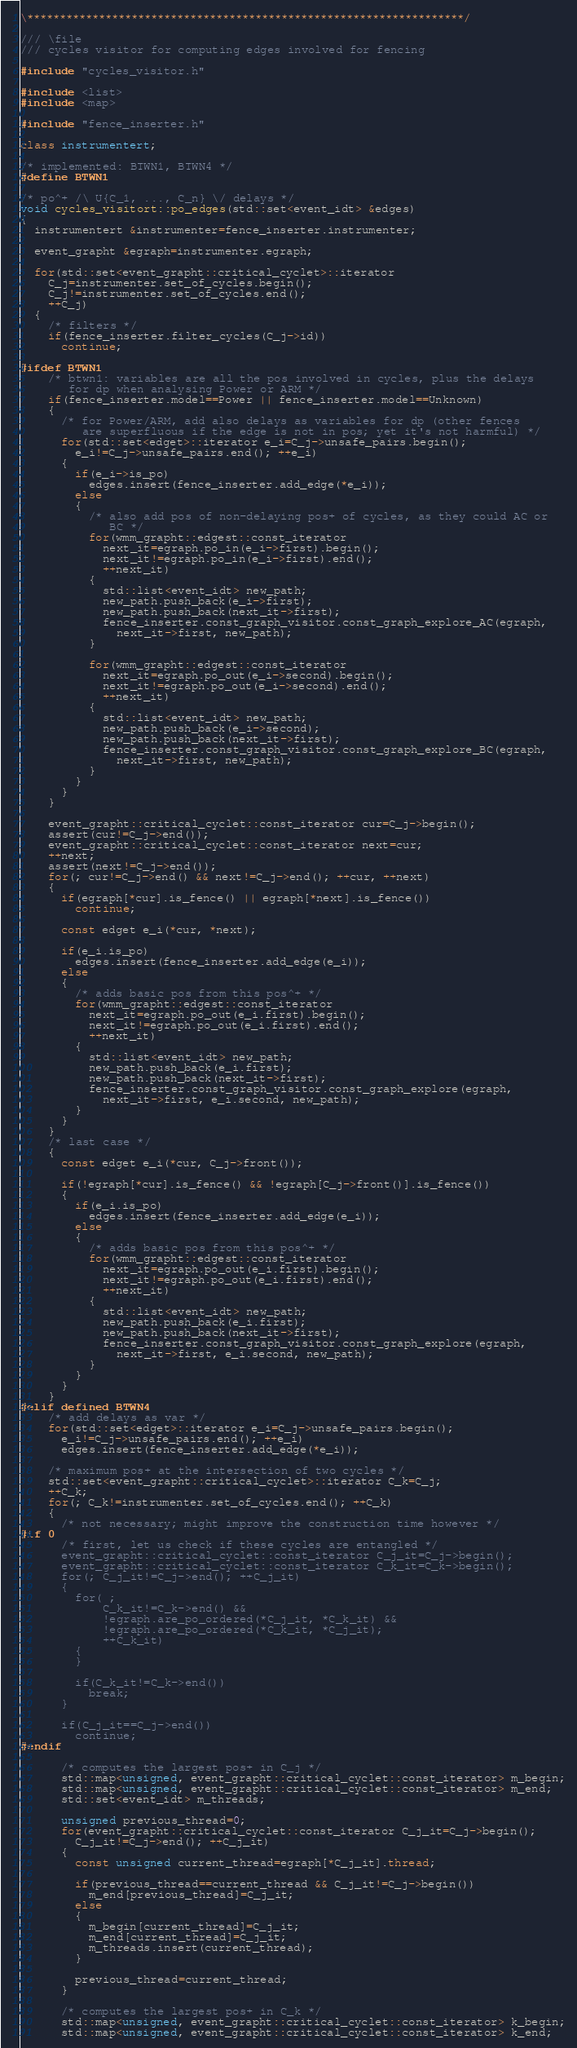<code> <loc_0><loc_0><loc_500><loc_500><_C++_>\*******************************************************************/

/// \file
/// cycles visitor for computing edges involved for fencing

#include "cycles_visitor.h"

#include <list>
#include <map>

#include "fence_inserter.h"

class instrumentert;

/* implemented: BTWN1, BTWN4 */
#define BTWN1

/* po^+ /\ U{C_1, ..., C_n} \/ delays */
void cycles_visitort::po_edges(std::set<event_idt> &edges)
{
  instrumentert &instrumenter=fence_inserter.instrumenter;

  event_grapht &egraph=instrumenter.egraph;

  for(std::set<event_grapht::critical_cyclet>::iterator
    C_j=instrumenter.set_of_cycles.begin();
    C_j!=instrumenter.set_of_cycles.end();
    ++C_j)
  {
    /* filters */
    if(fence_inserter.filter_cycles(C_j->id))
      continue;

#ifdef BTWN1
    /* btwn1: variables are all the pos involved in cycles, plus the delays
       for dp when analysing Power or ARM */
    if(fence_inserter.model==Power || fence_inserter.model==Unknown)
    {
      /* for Power/ARM, add also delays as variables for dp (other fences
         are superfluous if the edge is not in pos; yet it's not harmful) */
      for(std::set<edget>::iterator e_i=C_j->unsafe_pairs.begin();
        e_i!=C_j->unsafe_pairs.end(); ++e_i)
      {
        if(e_i->is_po)
          edges.insert(fence_inserter.add_edge(*e_i));
        else
        {
          /* also add pos of non-delaying pos+ of cycles, as they could AC or
             BC */
          for(wmm_grapht::edgest::const_iterator
            next_it=egraph.po_in(e_i->first).begin();
            next_it!=egraph.po_in(e_i->first).end();
            ++next_it)
          {
            std::list<event_idt> new_path;
            new_path.push_back(e_i->first);
            new_path.push_back(next_it->first);
            fence_inserter.const_graph_visitor.const_graph_explore_AC(egraph,
              next_it->first, new_path);
          }

          for(wmm_grapht::edgest::const_iterator
            next_it=egraph.po_out(e_i->second).begin();
            next_it!=egraph.po_out(e_i->second).end();
            ++next_it)
          {
            std::list<event_idt> new_path;
            new_path.push_back(e_i->second);
            new_path.push_back(next_it->first);
            fence_inserter.const_graph_visitor.const_graph_explore_BC(egraph,
              next_it->first, new_path);
          }
        }
      }
    }

    event_grapht::critical_cyclet::const_iterator cur=C_j->begin();
    assert(cur!=C_j->end());
    event_grapht::critical_cyclet::const_iterator next=cur;
    ++next;
    assert(next!=C_j->end());
    for(; cur!=C_j->end() && next!=C_j->end(); ++cur, ++next)
    {
      if(egraph[*cur].is_fence() || egraph[*next].is_fence())
        continue;

      const edget e_i(*cur, *next);

      if(e_i.is_po)
        edges.insert(fence_inserter.add_edge(e_i));
      else
      {
        /* adds basic pos from this pos^+ */
        for(wmm_grapht::edgest::const_iterator
          next_it=egraph.po_out(e_i.first).begin();
          next_it!=egraph.po_out(e_i.first).end();
          ++next_it)
        {
          std::list<event_idt> new_path;
          new_path.push_back(e_i.first);
          new_path.push_back(next_it->first);
          fence_inserter.const_graph_visitor.const_graph_explore(egraph,
            next_it->first, e_i.second, new_path);
        }
      }
    }
    /* last case */
    {
      const edget e_i(*cur, C_j->front());

      if(!egraph[*cur].is_fence() && !egraph[C_j->front()].is_fence())
      {
        if(e_i.is_po)
          edges.insert(fence_inserter.add_edge(e_i));
        else
        {
          /* adds basic pos from this pos^+ */
          for(wmm_grapht::edgest::const_iterator
            next_it=egraph.po_out(e_i.first).begin();
            next_it!=egraph.po_out(e_i.first).end();
            ++next_it)
          {
            std::list<event_idt> new_path;
            new_path.push_back(e_i.first);
            new_path.push_back(next_it->first);
            fence_inserter.const_graph_visitor.const_graph_explore(egraph,
              next_it->first, e_i.second, new_path);
          }
        }
      }
    }
#elif defined BTWN4
    /* add delays as var */
    for(std::set<edget>::iterator e_i=C_j->unsafe_pairs.begin();
      e_i!=C_j->unsafe_pairs.end(); ++e_i)
      edges.insert(fence_inserter.add_edge(*e_i));

    /* maximum pos+ at the intersection of two cycles */
    std::set<event_grapht::critical_cyclet>::iterator C_k=C_j;
    ++C_k;
    for(; C_k!=instrumenter.set_of_cycles.end(); ++C_k)
    {
      /* not necessary; might improve the construction time however */
#if 0
      /* first, let us check if these cycles are entangled */
      event_grapht::critical_cyclet::const_iterator C_j_it=C_j->begin();
      event_grapht::critical_cyclet::const_iterator C_k_it=C_k->begin();
      for(; C_j_it!=C_j->end(); ++C_j_it)
      {
        for( ;
            C_k_it!=C_k->end() &&
            !egraph.are_po_ordered(*C_j_it, *C_k_it) &&
            !egraph.are_po_ordered(*C_k_it, *C_j_it);
            ++C_k_it)
        {
        }

        if(C_k_it!=C_k->end())
          break;
      }

      if(C_j_it==C_j->end())
        continue;
#endif

      /* computes the largest pos+ in C_j */
      std::map<unsigned, event_grapht::critical_cyclet::const_iterator> m_begin;
      std::map<unsigned, event_grapht::critical_cyclet::const_iterator> m_end;
      std::set<event_idt> m_threads;

      unsigned previous_thread=0;
      for(event_grapht::critical_cyclet::const_iterator C_j_it=C_j->begin();
        C_j_it!=C_j->end(); ++C_j_it)
      {
        const unsigned current_thread=egraph[*C_j_it].thread;

        if(previous_thread==current_thread && C_j_it!=C_j->begin())
          m_end[previous_thread]=C_j_it;
        else
        {
          m_begin[current_thread]=C_j_it;
          m_end[current_thread]=C_j_it;
          m_threads.insert(current_thread);
        }

        previous_thread=current_thread;
      }

      /* computes the largest pos+ in C_k */
      std::map<unsigned, event_grapht::critical_cyclet::const_iterator> k_begin;
      std::map<unsigned, event_grapht::critical_cyclet::const_iterator> k_end;</code> 